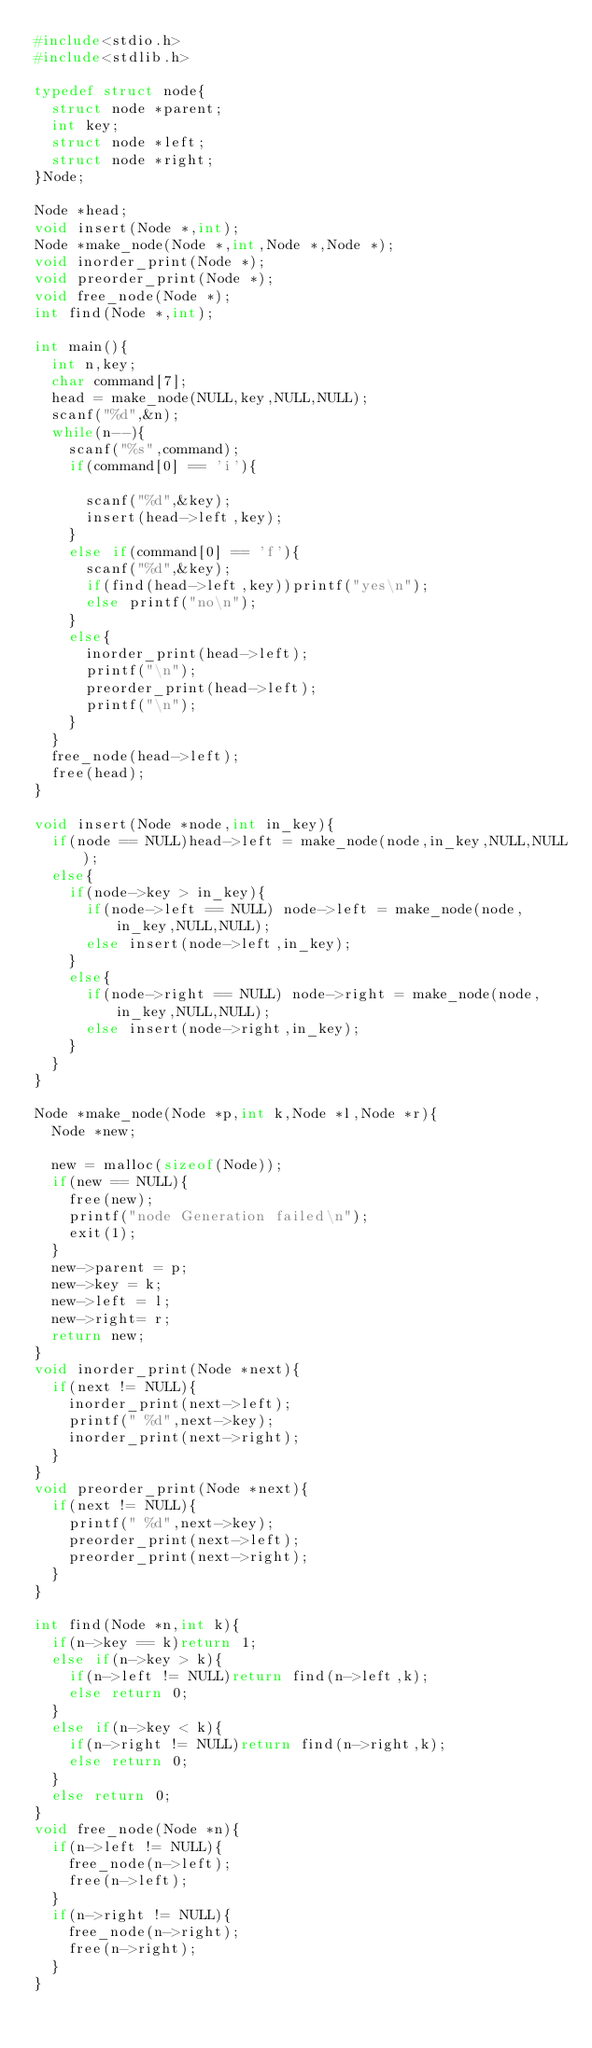<code> <loc_0><loc_0><loc_500><loc_500><_C_>#include<stdio.h>
#include<stdlib.h>

typedef struct node{
  struct node *parent;
  int key;
  struct node *left;
  struct node *right;
}Node;

Node *head;
void insert(Node *,int);
Node *make_node(Node *,int,Node *,Node *);
void inorder_print(Node *);
void preorder_print(Node *);
void free_node(Node *);
int find(Node *,int);

int main(){
  int n,key;
  char command[7];
  head = make_node(NULL,key,NULL,NULL);
  scanf("%d",&n);
  while(n--){
    scanf("%s",command);
    if(command[0] == 'i'){
     
      scanf("%d",&key);
      insert(head->left,key);
    }
    else if(command[0] == 'f'){
      scanf("%d",&key);
      if(find(head->left,key))printf("yes\n");
      else printf("no\n");
    } 
    else{
      inorder_print(head->left);
      printf("\n");
      preorder_print(head->left);
      printf("\n");
    }
  }
  free_node(head->left);
  free(head);
}

void insert(Node *node,int in_key){
  if(node == NULL)head->left = make_node(node,in_key,NULL,NULL);
  else{
    if(node->key > in_key){
      if(node->left == NULL) node->left = make_node(node,in_key,NULL,NULL);
      else insert(node->left,in_key);
    }
    else{
      if(node->right == NULL) node->right = make_node(node,in_key,NULL,NULL);
      else insert(node->right,in_key);
    }
  }
}

Node *make_node(Node *p,int k,Node *l,Node *r){
  Node *new;

  new = malloc(sizeof(Node));
  if(new == NULL){
    free(new);
    printf("node Generation failed\n");
    exit(1);
  }
  new->parent = p;
  new->key = k;
  new->left = l; 
  new->right= r;
  return new;
}
void inorder_print(Node *next){
  if(next != NULL){
    inorder_print(next->left);
    printf(" %d",next->key);
    inorder_print(next->right);
  }
}
void preorder_print(Node *next){
  if(next != NULL){
    printf(" %d",next->key);
    preorder_print(next->left);
    preorder_print(next->right);
  }
}

int find(Node *n,int k){
  if(n->key == k)return 1;
  else if(n->key > k){
    if(n->left != NULL)return find(n->left,k);
    else return 0;
  }
  else if(n->key < k){
    if(n->right != NULL)return find(n->right,k);
    else return 0;
  }
  else return 0;
}
void free_node(Node *n){
  if(n->left != NULL){
    free_node(n->left);
    free(n->left);
  }
  if(n->right != NULL){
    free_node(n->right);
    free(n->right);
  }
}
</code> 